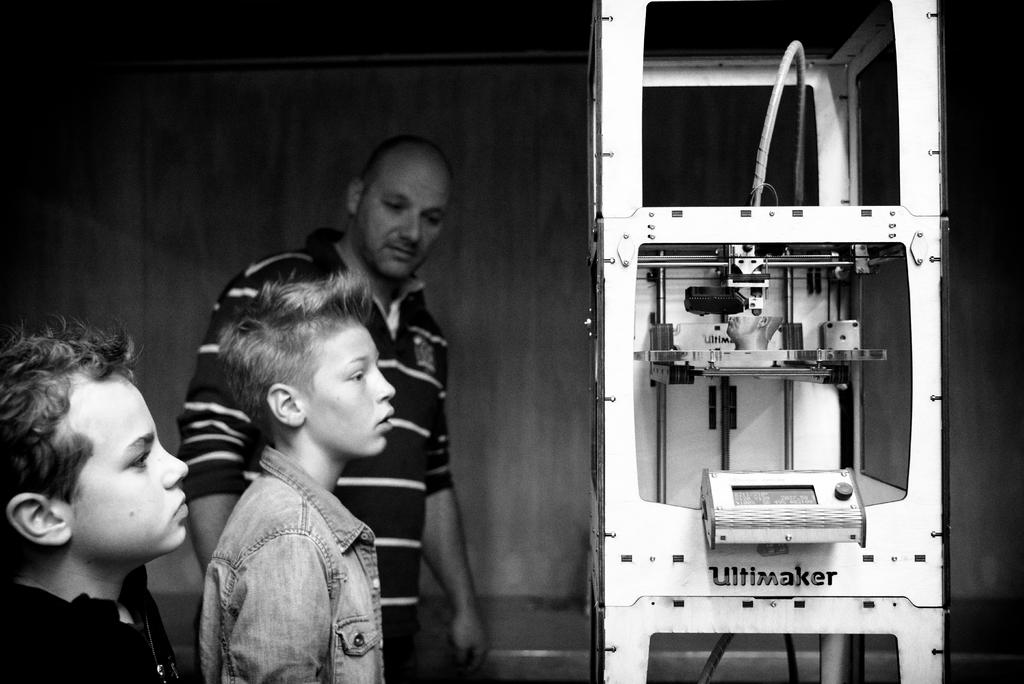How many people are present in the image? There are three people standing in the image. What can be seen on the right side of the image? There is a machine on the right side of the image. What is visible in the background of the image? There is a wall in the background of the image. What type of quince is being used to power the machine in the image? There is no quince present in the image, and the machine's power source is not mentioned. How many apples are being used to build the wall in the background? There are no apples present in the image, and the wall's construction materials are not mentioned. 